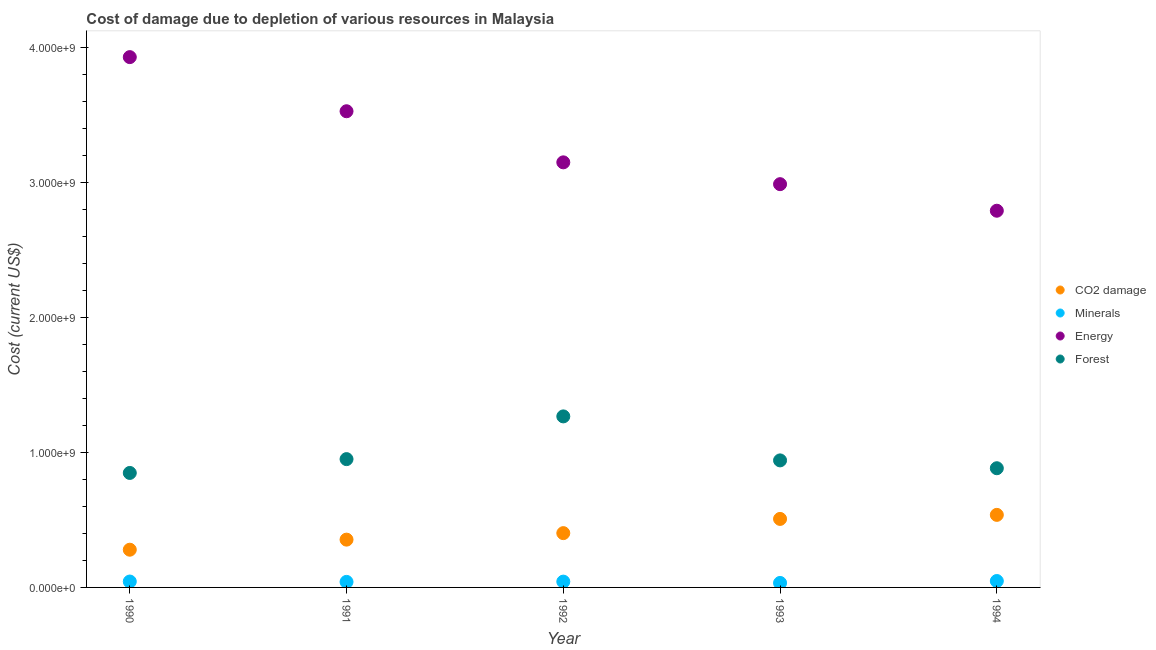What is the cost of damage due to depletion of energy in 1994?
Provide a short and direct response. 2.79e+09. Across all years, what is the maximum cost of damage due to depletion of forests?
Your answer should be compact. 1.27e+09. Across all years, what is the minimum cost of damage due to depletion of forests?
Offer a very short reply. 8.49e+08. In which year was the cost of damage due to depletion of minerals maximum?
Offer a very short reply. 1994. What is the total cost of damage due to depletion of coal in the graph?
Ensure brevity in your answer.  2.08e+09. What is the difference between the cost of damage due to depletion of coal in 1991 and that in 1992?
Your answer should be compact. -4.82e+07. What is the difference between the cost of damage due to depletion of minerals in 1993 and the cost of damage due to depletion of energy in 1992?
Your answer should be compact. -3.12e+09. What is the average cost of damage due to depletion of minerals per year?
Offer a very short reply. 4.17e+07. In the year 1994, what is the difference between the cost of damage due to depletion of minerals and cost of damage due to depletion of coal?
Your response must be concise. -4.90e+08. What is the ratio of the cost of damage due to depletion of energy in 1991 to that in 1994?
Make the answer very short. 1.26. Is the cost of damage due to depletion of minerals in 1990 less than that in 1993?
Offer a very short reply. No. What is the difference between the highest and the second highest cost of damage due to depletion of coal?
Provide a succinct answer. 3.00e+07. What is the difference between the highest and the lowest cost of damage due to depletion of forests?
Provide a succinct answer. 4.19e+08. In how many years, is the cost of damage due to depletion of minerals greater than the average cost of damage due to depletion of minerals taken over all years?
Your answer should be very brief. 3. Is it the case that in every year, the sum of the cost of damage due to depletion of coal and cost of damage due to depletion of minerals is greater than the cost of damage due to depletion of energy?
Make the answer very short. No. Is the cost of damage due to depletion of energy strictly less than the cost of damage due to depletion of minerals over the years?
Your answer should be compact. No. How many dotlines are there?
Provide a short and direct response. 4. What is the difference between two consecutive major ticks on the Y-axis?
Your answer should be compact. 1.00e+09. Does the graph contain grids?
Offer a very short reply. No. How many legend labels are there?
Provide a succinct answer. 4. What is the title of the graph?
Offer a very short reply. Cost of damage due to depletion of various resources in Malaysia . What is the label or title of the Y-axis?
Provide a short and direct response. Cost (current US$). What is the Cost (current US$) in CO2 damage in 1990?
Offer a terse response. 2.80e+08. What is the Cost (current US$) of Minerals in 1990?
Offer a very short reply. 4.37e+07. What is the Cost (current US$) of Energy in 1990?
Keep it short and to the point. 3.93e+09. What is the Cost (current US$) in Forest in 1990?
Provide a short and direct response. 8.49e+08. What is the Cost (current US$) in CO2 damage in 1991?
Ensure brevity in your answer.  3.54e+08. What is the Cost (current US$) in Minerals in 1991?
Give a very brief answer. 4.10e+07. What is the Cost (current US$) in Energy in 1991?
Make the answer very short. 3.53e+09. What is the Cost (current US$) in Forest in 1991?
Give a very brief answer. 9.51e+08. What is the Cost (current US$) in CO2 damage in 1992?
Keep it short and to the point. 4.03e+08. What is the Cost (current US$) in Minerals in 1992?
Your response must be concise. 4.31e+07. What is the Cost (current US$) of Energy in 1992?
Give a very brief answer. 3.15e+09. What is the Cost (current US$) in Forest in 1992?
Provide a succinct answer. 1.27e+09. What is the Cost (current US$) of CO2 damage in 1993?
Offer a terse response. 5.08e+08. What is the Cost (current US$) of Minerals in 1993?
Your response must be concise. 3.32e+07. What is the Cost (current US$) of Energy in 1993?
Your answer should be very brief. 2.99e+09. What is the Cost (current US$) of Forest in 1993?
Ensure brevity in your answer.  9.42e+08. What is the Cost (current US$) in CO2 damage in 1994?
Ensure brevity in your answer.  5.38e+08. What is the Cost (current US$) of Minerals in 1994?
Keep it short and to the point. 4.75e+07. What is the Cost (current US$) of Energy in 1994?
Your answer should be very brief. 2.79e+09. What is the Cost (current US$) of Forest in 1994?
Provide a short and direct response. 8.84e+08. Across all years, what is the maximum Cost (current US$) of CO2 damage?
Offer a very short reply. 5.38e+08. Across all years, what is the maximum Cost (current US$) in Minerals?
Your response must be concise. 4.75e+07. Across all years, what is the maximum Cost (current US$) of Energy?
Keep it short and to the point. 3.93e+09. Across all years, what is the maximum Cost (current US$) in Forest?
Ensure brevity in your answer.  1.27e+09. Across all years, what is the minimum Cost (current US$) of CO2 damage?
Your response must be concise. 2.80e+08. Across all years, what is the minimum Cost (current US$) of Minerals?
Your answer should be compact. 3.32e+07. Across all years, what is the minimum Cost (current US$) of Energy?
Ensure brevity in your answer.  2.79e+09. Across all years, what is the minimum Cost (current US$) in Forest?
Keep it short and to the point. 8.49e+08. What is the total Cost (current US$) of CO2 damage in the graph?
Keep it short and to the point. 2.08e+09. What is the total Cost (current US$) of Minerals in the graph?
Keep it short and to the point. 2.09e+08. What is the total Cost (current US$) in Energy in the graph?
Offer a terse response. 1.64e+1. What is the total Cost (current US$) in Forest in the graph?
Offer a terse response. 4.89e+09. What is the difference between the Cost (current US$) in CO2 damage in 1990 and that in 1991?
Your answer should be very brief. -7.47e+07. What is the difference between the Cost (current US$) of Minerals in 1990 and that in 1991?
Keep it short and to the point. 2.69e+06. What is the difference between the Cost (current US$) in Energy in 1990 and that in 1991?
Make the answer very short. 4.01e+08. What is the difference between the Cost (current US$) of Forest in 1990 and that in 1991?
Your response must be concise. -1.02e+08. What is the difference between the Cost (current US$) in CO2 damage in 1990 and that in 1992?
Ensure brevity in your answer.  -1.23e+08. What is the difference between the Cost (current US$) of Minerals in 1990 and that in 1992?
Give a very brief answer. 6.63e+05. What is the difference between the Cost (current US$) in Energy in 1990 and that in 1992?
Provide a succinct answer. 7.80e+08. What is the difference between the Cost (current US$) of Forest in 1990 and that in 1992?
Your answer should be very brief. -4.19e+08. What is the difference between the Cost (current US$) of CO2 damage in 1990 and that in 1993?
Your response must be concise. -2.28e+08. What is the difference between the Cost (current US$) of Minerals in 1990 and that in 1993?
Keep it short and to the point. 1.05e+07. What is the difference between the Cost (current US$) in Energy in 1990 and that in 1993?
Offer a very short reply. 9.42e+08. What is the difference between the Cost (current US$) of Forest in 1990 and that in 1993?
Your response must be concise. -9.30e+07. What is the difference between the Cost (current US$) in CO2 damage in 1990 and that in 1994?
Ensure brevity in your answer.  -2.58e+08. What is the difference between the Cost (current US$) in Minerals in 1990 and that in 1994?
Provide a succinct answer. -3.78e+06. What is the difference between the Cost (current US$) of Energy in 1990 and that in 1994?
Your response must be concise. 1.14e+09. What is the difference between the Cost (current US$) of Forest in 1990 and that in 1994?
Your answer should be very brief. -3.49e+07. What is the difference between the Cost (current US$) of CO2 damage in 1991 and that in 1992?
Your answer should be very brief. -4.82e+07. What is the difference between the Cost (current US$) in Minerals in 1991 and that in 1992?
Give a very brief answer. -2.03e+06. What is the difference between the Cost (current US$) of Energy in 1991 and that in 1992?
Keep it short and to the point. 3.79e+08. What is the difference between the Cost (current US$) in Forest in 1991 and that in 1992?
Provide a short and direct response. -3.17e+08. What is the difference between the Cost (current US$) in CO2 damage in 1991 and that in 1993?
Provide a short and direct response. -1.54e+08. What is the difference between the Cost (current US$) of Minerals in 1991 and that in 1993?
Give a very brief answer. 7.81e+06. What is the difference between the Cost (current US$) of Energy in 1991 and that in 1993?
Keep it short and to the point. 5.41e+08. What is the difference between the Cost (current US$) in Forest in 1991 and that in 1993?
Your answer should be very brief. 9.41e+06. What is the difference between the Cost (current US$) in CO2 damage in 1991 and that in 1994?
Keep it short and to the point. -1.84e+08. What is the difference between the Cost (current US$) of Minerals in 1991 and that in 1994?
Give a very brief answer. -6.47e+06. What is the difference between the Cost (current US$) in Energy in 1991 and that in 1994?
Offer a terse response. 7.38e+08. What is the difference between the Cost (current US$) of Forest in 1991 and that in 1994?
Make the answer very short. 6.75e+07. What is the difference between the Cost (current US$) of CO2 damage in 1992 and that in 1993?
Offer a terse response. -1.05e+08. What is the difference between the Cost (current US$) in Minerals in 1992 and that in 1993?
Provide a succinct answer. 9.84e+06. What is the difference between the Cost (current US$) in Energy in 1992 and that in 1993?
Provide a succinct answer. 1.62e+08. What is the difference between the Cost (current US$) of Forest in 1992 and that in 1993?
Make the answer very short. 3.26e+08. What is the difference between the Cost (current US$) in CO2 damage in 1992 and that in 1994?
Provide a short and direct response. -1.35e+08. What is the difference between the Cost (current US$) in Minerals in 1992 and that in 1994?
Your answer should be very brief. -4.44e+06. What is the difference between the Cost (current US$) of Energy in 1992 and that in 1994?
Give a very brief answer. 3.59e+08. What is the difference between the Cost (current US$) in Forest in 1992 and that in 1994?
Your response must be concise. 3.84e+08. What is the difference between the Cost (current US$) of CO2 damage in 1993 and that in 1994?
Your answer should be very brief. -3.00e+07. What is the difference between the Cost (current US$) in Minerals in 1993 and that in 1994?
Give a very brief answer. -1.43e+07. What is the difference between the Cost (current US$) in Energy in 1993 and that in 1994?
Provide a short and direct response. 1.97e+08. What is the difference between the Cost (current US$) of Forest in 1993 and that in 1994?
Offer a very short reply. 5.81e+07. What is the difference between the Cost (current US$) in CO2 damage in 1990 and the Cost (current US$) in Minerals in 1991?
Offer a very short reply. 2.39e+08. What is the difference between the Cost (current US$) in CO2 damage in 1990 and the Cost (current US$) in Energy in 1991?
Your answer should be very brief. -3.25e+09. What is the difference between the Cost (current US$) of CO2 damage in 1990 and the Cost (current US$) of Forest in 1991?
Make the answer very short. -6.72e+08. What is the difference between the Cost (current US$) in Minerals in 1990 and the Cost (current US$) in Energy in 1991?
Ensure brevity in your answer.  -3.49e+09. What is the difference between the Cost (current US$) in Minerals in 1990 and the Cost (current US$) in Forest in 1991?
Give a very brief answer. -9.08e+08. What is the difference between the Cost (current US$) in Energy in 1990 and the Cost (current US$) in Forest in 1991?
Keep it short and to the point. 2.98e+09. What is the difference between the Cost (current US$) of CO2 damage in 1990 and the Cost (current US$) of Minerals in 1992?
Provide a short and direct response. 2.37e+08. What is the difference between the Cost (current US$) of CO2 damage in 1990 and the Cost (current US$) of Energy in 1992?
Give a very brief answer. -2.87e+09. What is the difference between the Cost (current US$) in CO2 damage in 1990 and the Cost (current US$) in Forest in 1992?
Your answer should be compact. -9.88e+08. What is the difference between the Cost (current US$) of Minerals in 1990 and the Cost (current US$) of Energy in 1992?
Your answer should be compact. -3.11e+09. What is the difference between the Cost (current US$) of Minerals in 1990 and the Cost (current US$) of Forest in 1992?
Make the answer very short. -1.22e+09. What is the difference between the Cost (current US$) in Energy in 1990 and the Cost (current US$) in Forest in 1992?
Your response must be concise. 2.66e+09. What is the difference between the Cost (current US$) in CO2 damage in 1990 and the Cost (current US$) in Minerals in 1993?
Offer a very short reply. 2.46e+08. What is the difference between the Cost (current US$) of CO2 damage in 1990 and the Cost (current US$) of Energy in 1993?
Make the answer very short. -2.71e+09. What is the difference between the Cost (current US$) in CO2 damage in 1990 and the Cost (current US$) in Forest in 1993?
Your answer should be very brief. -6.62e+08. What is the difference between the Cost (current US$) of Minerals in 1990 and the Cost (current US$) of Energy in 1993?
Make the answer very short. -2.95e+09. What is the difference between the Cost (current US$) of Minerals in 1990 and the Cost (current US$) of Forest in 1993?
Your response must be concise. -8.98e+08. What is the difference between the Cost (current US$) in Energy in 1990 and the Cost (current US$) in Forest in 1993?
Your response must be concise. 2.99e+09. What is the difference between the Cost (current US$) of CO2 damage in 1990 and the Cost (current US$) of Minerals in 1994?
Provide a succinct answer. 2.32e+08. What is the difference between the Cost (current US$) in CO2 damage in 1990 and the Cost (current US$) in Energy in 1994?
Offer a very short reply. -2.51e+09. What is the difference between the Cost (current US$) in CO2 damage in 1990 and the Cost (current US$) in Forest in 1994?
Your answer should be very brief. -6.04e+08. What is the difference between the Cost (current US$) in Minerals in 1990 and the Cost (current US$) in Energy in 1994?
Give a very brief answer. -2.75e+09. What is the difference between the Cost (current US$) of Minerals in 1990 and the Cost (current US$) of Forest in 1994?
Your answer should be very brief. -8.40e+08. What is the difference between the Cost (current US$) in Energy in 1990 and the Cost (current US$) in Forest in 1994?
Your response must be concise. 3.05e+09. What is the difference between the Cost (current US$) in CO2 damage in 1991 and the Cost (current US$) in Minerals in 1992?
Your response must be concise. 3.11e+08. What is the difference between the Cost (current US$) in CO2 damage in 1991 and the Cost (current US$) in Energy in 1992?
Offer a terse response. -2.80e+09. What is the difference between the Cost (current US$) in CO2 damage in 1991 and the Cost (current US$) in Forest in 1992?
Offer a terse response. -9.14e+08. What is the difference between the Cost (current US$) of Minerals in 1991 and the Cost (current US$) of Energy in 1992?
Offer a very short reply. -3.11e+09. What is the difference between the Cost (current US$) of Minerals in 1991 and the Cost (current US$) of Forest in 1992?
Your response must be concise. -1.23e+09. What is the difference between the Cost (current US$) of Energy in 1991 and the Cost (current US$) of Forest in 1992?
Offer a very short reply. 2.26e+09. What is the difference between the Cost (current US$) of CO2 damage in 1991 and the Cost (current US$) of Minerals in 1993?
Provide a short and direct response. 3.21e+08. What is the difference between the Cost (current US$) in CO2 damage in 1991 and the Cost (current US$) in Energy in 1993?
Offer a very short reply. -2.64e+09. What is the difference between the Cost (current US$) in CO2 damage in 1991 and the Cost (current US$) in Forest in 1993?
Ensure brevity in your answer.  -5.87e+08. What is the difference between the Cost (current US$) in Minerals in 1991 and the Cost (current US$) in Energy in 1993?
Offer a very short reply. -2.95e+09. What is the difference between the Cost (current US$) of Minerals in 1991 and the Cost (current US$) of Forest in 1993?
Give a very brief answer. -9.01e+08. What is the difference between the Cost (current US$) of Energy in 1991 and the Cost (current US$) of Forest in 1993?
Provide a succinct answer. 2.59e+09. What is the difference between the Cost (current US$) in CO2 damage in 1991 and the Cost (current US$) in Minerals in 1994?
Provide a succinct answer. 3.07e+08. What is the difference between the Cost (current US$) of CO2 damage in 1991 and the Cost (current US$) of Energy in 1994?
Give a very brief answer. -2.44e+09. What is the difference between the Cost (current US$) of CO2 damage in 1991 and the Cost (current US$) of Forest in 1994?
Give a very brief answer. -5.29e+08. What is the difference between the Cost (current US$) in Minerals in 1991 and the Cost (current US$) in Energy in 1994?
Your answer should be compact. -2.75e+09. What is the difference between the Cost (current US$) of Minerals in 1991 and the Cost (current US$) of Forest in 1994?
Ensure brevity in your answer.  -8.43e+08. What is the difference between the Cost (current US$) of Energy in 1991 and the Cost (current US$) of Forest in 1994?
Make the answer very short. 2.65e+09. What is the difference between the Cost (current US$) in CO2 damage in 1992 and the Cost (current US$) in Minerals in 1993?
Provide a succinct answer. 3.69e+08. What is the difference between the Cost (current US$) of CO2 damage in 1992 and the Cost (current US$) of Energy in 1993?
Make the answer very short. -2.59e+09. What is the difference between the Cost (current US$) in CO2 damage in 1992 and the Cost (current US$) in Forest in 1993?
Provide a succinct answer. -5.39e+08. What is the difference between the Cost (current US$) of Minerals in 1992 and the Cost (current US$) of Energy in 1993?
Offer a terse response. -2.95e+09. What is the difference between the Cost (current US$) in Minerals in 1992 and the Cost (current US$) in Forest in 1993?
Offer a terse response. -8.99e+08. What is the difference between the Cost (current US$) of Energy in 1992 and the Cost (current US$) of Forest in 1993?
Give a very brief answer. 2.21e+09. What is the difference between the Cost (current US$) of CO2 damage in 1992 and the Cost (current US$) of Minerals in 1994?
Make the answer very short. 3.55e+08. What is the difference between the Cost (current US$) of CO2 damage in 1992 and the Cost (current US$) of Energy in 1994?
Provide a succinct answer. -2.39e+09. What is the difference between the Cost (current US$) in CO2 damage in 1992 and the Cost (current US$) in Forest in 1994?
Provide a short and direct response. -4.81e+08. What is the difference between the Cost (current US$) in Minerals in 1992 and the Cost (current US$) in Energy in 1994?
Your answer should be very brief. -2.75e+09. What is the difference between the Cost (current US$) in Minerals in 1992 and the Cost (current US$) in Forest in 1994?
Offer a very short reply. -8.41e+08. What is the difference between the Cost (current US$) of Energy in 1992 and the Cost (current US$) of Forest in 1994?
Make the answer very short. 2.27e+09. What is the difference between the Cost (current US$) of CO2 damage in 1993 and the Cost (current US$) of Minerals in 1994?
Offer a terse response. 4.60e+08. What is the difference between the Cost (current US$) in CO2 damage in 1993 and the Cost (current US$) in Energy in 1994?
Provide a succinct answer. -2.28e+09. What is the difference between the Cost (current US$) of CO2 damage in 1993 and the Cost (current US$) of Forest in 1994?
Your answer should be compact. -3.76e+08. What is the difference between the Cost (current US$) in Minerals in 1993 and the Cost (current US$) in Energy in 1994?
Your answer should be very brief. -2.76e+09. What is the difference between the Cost (current US$) in Minerals in 1993 and the Cost (current US$) in Forest in 1994?
Your response must be concise. -8.50e+08. What is the difference between the Cost (current US$) in Energy in 1993 and the Cost (current US$) in Forest in 1994?
Provide a short and direct response. 2.11e+09. What is the average Cost (current US$) of CO2 damage per year?
Your response must be concise. 4.16e+08. What is the average Cost (current US$) of Minerals per year?
Offer a very short reply. 4.17e+07. What is the average Cost (current US$) in Energy per year?
Offer a terse response. 3.28e+09. What is the average Cost (current US$) in Forest per year?
Your response must be concise. 9.79e+08. In the year 1990, what is the difference between the Cost (current US$) in CO2 damage and Cost (current US$) in Minerals?
Provide a succinct answer. 2.36e+08. In the year 1990, what is the difference between the Cost (current US$) in CO2 damage and Cost (current US$) in Energy?
Your answer should be very brief. -3.65e+09. In the year 1990, what is the difference between the Cost (current US$) of CO2 damage and Cost (current US$) of Forest?
Provide a succinct answer. -5.69e+08. In the year 1990, what is the difference between the Cost (current US$) in Minerals and Cost (current US$) in Energy?
Keep it short and to the point. -3.89e+09. In the year 1990, what is the difference between the Cost (current US$) of Minerals and Cost (current US$) of Forest?
Ensure brevity in your answer.  -8.05e+08. In the year 1990, what is the difference between the Cost (current US$) in Energy and Cost (current US$) in Forest?
Ensure brevity in your answer.  3.08e+09. In the year 1991, what is the difference between the Cost (current US$) in CO2 damage and Cost (current US$) in Minerals?
Provide a succinct answer. 3.13e+08. In the year 1991, what is the difference between the Cost (current US$) of CO2 damage and Cost (current US$) of Energy?
Your answer should be compact. -3.18e+09. In the year 1991, what is the difference between the Cost (current US$) of CO2 damage and Cost (current US$) of Forest?
Offer a very short reply. -5.97e+08. In the year 1991, what is the difference between the Cost (current US$) of Minerals and Cost (current US$) of Energy?
Ensure brevity in your answer.  -3.49e+09. In the year 1991, what is the difference between the Cost (current US$) of Minerals and Cost (current US$) of Forest?
Your response must be concise. -9.10e+08. In the year 1991, what is the difference between the Cost (current US$) of Energy and Cost (current US$) of Forest?
Your answer should be compact. 2.58e+09. In the year 1992, what is the difference between the Cost (current US$) in CO2 damage and Cost (current US$) in Minerals?
Offer a terse response. 3.59e+08. In the year 1992, what is the difference between the Cost (current US$) of CO2 damage and Cost (current US$) of Energy?
Your answer should be compact. -2.75e+09. In the year 1992, what is the difference between the Cost (current US$) in CO2 damage and Cost (current US$) in Forest?
Offer a terse response. -8.65e+08. In the year 1992, what is the difference between the Cost (current US$) of Minerals and Cost (current US$) of Energy?
Provide a short and direct response. -3.11e+09. In the year 1992, what is the difference between the Cost (current US$) in Minerals and Cost (current US$) in Forest?
Keep it short and to the point. -1.22e+09. In the year 1992, what is the difference between the Cost (current US$) in Energy and Cost (current US$) in Forest?
Offer a very short reply. 1.88e+09. In the year 1993, what is the difference between the Cost (current US$) in CO2 damage and Cost (current US$) in Minerals?
Your answer should be compact. 4.75e+08. In the year 1993, what is the difference between the Cost (current US$) in CO2 damage and Cost (current US$) in Energy?
Make the answer very short. -2.48e+09. In the year 1993, what is the difference between the Cost (current US$) of CO2 damage and Cost (current US$) of Forest?
Offer a terse response. -4.34e+08. In the year 1993, what is the difference between the Cost (current US$) in Minerals and Cost (current US$) in Energy?
Your answer should be compact. -2.96e+09. In the year 1993, what is the difference between the Cost (current US$) in Minerals and Cost (current US$) in Forest?
Keep it short and to the point. -9.09e+08. In the year 1993, what is the difference between the Cost (current US$) in Energy and Cost (current US$) in Forest?
Ensure brevity in your answer.  2.05e+09. In the year 1994, what is the difference between the Cost (current US$) in CO2 damage and Cost (current US$) in Minerals?
Keep it short and to the point. 4.90e+08. In the year 1994, what is the difference between the Cost (current US$) of CO2 damage and Cost (current US$) of Energy?
Give a very brief answer. -2.25e+09. In the year 1994, what is the difference between the Cost (current US$) in CO2 damage and Cost (current US$) in Forest?
Your answer should be compact. -3.46e+08. In the year 1994, what is the difference between the Cost (current US$) in Minerals and Cost (current US$) in Energy?
Ensure brevity in your answer.  -2.75e+09. In the year 1994, what is the difference between the Cost (current US$) of Minerals and Cost (current US$) of Forest?
Your answer should be compact. -8.36e+08. In the year 1994, what is the difference between the Cost (current US$) in Energy and Cost (current US$) in Forest?
Offer a very short reply. 1.91e+09. What is the ratio of the Cost (current US$) in CO2 damage in 1990 to that in 1991?
Keep it short and to the point. 0.79. What is the ratio of the Cost (current US$) in Minerals in 1990 to that in 1991?
Keep it short and to the point. 1.07. What is the ratio of the Cost (current US$) in Energy in 1990 to that in 1991?
Ensure brevity in your answer.  1.11. What is the ratio of the Cost (current US$) in Forest in 1990 to that in 1991?
Ensure brevity in your answer.  0.89. What is the ratio of the Cost (current US$) of CO2 damage in 1990 to that in 1992?
Give a very brief answer. 0.69. What is the ratio of the Cost (current US$) of Minerals in 1990 to that in 1992?
Provide a succinct answer. 1.02. What is the ratio of the Cost (current US$) of Energy in 1990 to that in 1992?
Your answer should be compact. 1.25. What is the ratio of the Cost (current US$) of Forest in 1990 to that in 1992?
Your response must be concise. 0.67. What is the ratio of the Cost (current US$) of CO2 damage in 1990 to that in 1993?
Keep it short and to the point. 0.55. What is the ratio of the Cost (current US$) in Minerals in 1990 to that in 1993?
Provide a succinct answer. 1.32. What is the ratio of the Cost (current US$) of Energy in 1990 to that in 1993?
Keep it short and to the point. 1.31. What is the ratio of the Cost (current US$) of Forest in 1990 to that in 1993?
Keep it short and to the point. 0.9. What is the ratio of the Cost (current US$) of CO2 damage in 1990 to that in 1994?
Your answer should be very brief. 0.52. What is the ratio of the Cost (current US$) in Minerals in 1990 to that in 1994?
Provide a short and direct response. 0.92. What is the ratio of the Cost (current US$) in Energy in 1990 to that in 1994?
Provide a short and direct response. 1.41. What is the ratio of the Cost (current US$) of Forest in 1990 to that in 1994?
Offer a very short reply. 0.96. What is the ratio of the Cost (current US$) of CO2 damage in 1991 to that in 1992?
Offer a very short reply. 0.88. What is the ratio of the Cost (current US$) in Minerals in 1991 to that in 1992?
Provide a short and direct response. 0.95. What is the ratio of the Cost (current US$) in Energy in 1991 to that in 1992?
Your answer should be very brief. 1.12. What is the ratio of the Cost (current US$) of Forest in 1991 to that in 1992?
Your answer should be very brief. 0.75. What is the ratio of the Cost (current US$) in CO2 damage in 1991 to that in 1993?
Your answer should be compact. 0.7. What is the ratio of the Cost (current US$) of Minerals in 1991 to that in 1993?
Your answer should be compact. 1.24. What is the ratio of the Cost (current US$) in Energy in 1991 to that in 1993?
Your response must be concise. 1.18. What is the ratio of the Cost (current US$) in CO2 damage in 1991 to that in 1994?
Offer a terse response. 0.66. What is the ratio of the Cost (current US$) in Minerals in 1991 to that in 1994?
Offer a terse response. 0.86. What is the ratio of the Cost (current US$) of Energy in 1991 to that in 1994?
Your answer should be compact. 1.26. What is the ratio of the Cost (current US$) in Forest in 1991 to that in 1994?
Offer a terse response. 1.08. What is the ratio of the Cost (current US$) of CO2 damage in 1992 to that in 1993?
Your response must be concise. 0.79. What is the ratio of the Cost (current US$) in Minerals in 1992 to that in 1993?
Ensure brevity in your answer.  1.3. What is the ratio of the Cost (current US$) in Energy in 1992 to that in 1993?
Give a very brief answer. 1.05. What is the ratio of the Cost (current US$) of Forest in 1992 to that in 1993?
Offer a very short reply. 1.35. What is the ratio of the Cost (current US$) in CO2 damage in 1992 to that in 1994?
Your response must be concise. 0.75. What is the ratio of the Cost (current US$) in Minerals in 1992 to that in 1994?
Your answer should be compact. 0.91. What is the ratio of the Cost (current US$) of Energy in 1992 to that in 1994?
Keep it short and to the point. 1.13. What is the ratio of the Cost (current US$) in Forest in 1992 to that in 1994?
Ensure brevity in your answer.  1.43. What is the ratio of the Cost (current US$) of CO2 damage in 1993 to that in 1994?
Offer a very short reply. 0.94. What is the ratio of the Cost (current US$) in Minerals in 1993 to that in 1994?
Give a very brief answer. 0.7. What is the ratio of the Cost (current US$) of Energy in 1993 to that in 1994?
Ensure brevity in your answer.  1.07. What is the ratio of the Cost (current US$) of Forest in 1993 to that in 1994?
Keep it short and to the point. 1.07. What is the difference between the highest and the second highest Cost (current US$) in CO2 damage?
Ensure brevity in your answer.  3.00e+07. What is the difference between the highest and the second highest Cost (current US$) of Minerals?
Offer a very short reply. 3.78e+06. What is the difference between the highest and the second highest Cost (current US$) of Energy?
Your answer should be compact. 4.01e+08. What is the difference between the highest and the second highest Cost (current US$) in Forest?
Ensure brevity in your answer.  3.17e+08. What is the difference between the highest and the lowest Cost (current US$) in CO2 damage?
Your answer should be very brief. 2.58e+08. What is the difference between the highest and the lowest Cost (current US$) of Minerals?
Offer a terse response. 1.43e+07. What is the difference between the highest and the lowest Cost (current US$) in Energy?
Offer a very short reply. 1.14e+09. What is the difference between the highest and the lowest Cost (current US$) in Forest?
Offer a terse response. 4.19e+08. 